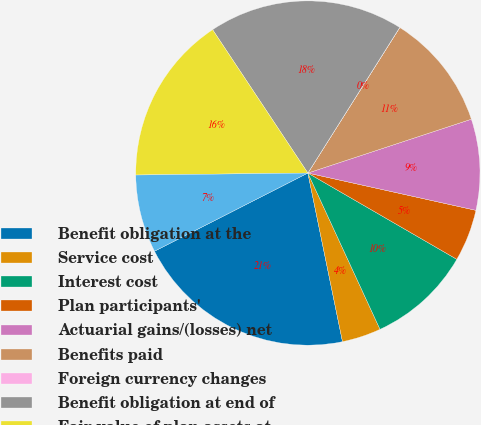Convert chart. <chart><loc_0><loc_0><loc_500><loc_500><pie_chart><fcel>Benefit obligation at the<fcel>Service cost<fcel>Interest cost<fcel>Plan participants'<fcel>Actuarial gains/(losses) net<fcel>Benefits paid<fcel>Foreign currency changes<fcel>Benefit obligation at end of<fcel>Fair value of plan assets at<fcel>Actual return on plan assets<nl><fcel>20.72%<fcel>3.66%<fcel>9.76%<fcel>4.88%<fcel>8.54%<fcel>10.97%<fcel>0.01%<fcel>18.29%<fcel>15.85%<fcel>7.32%<nl></chart> 